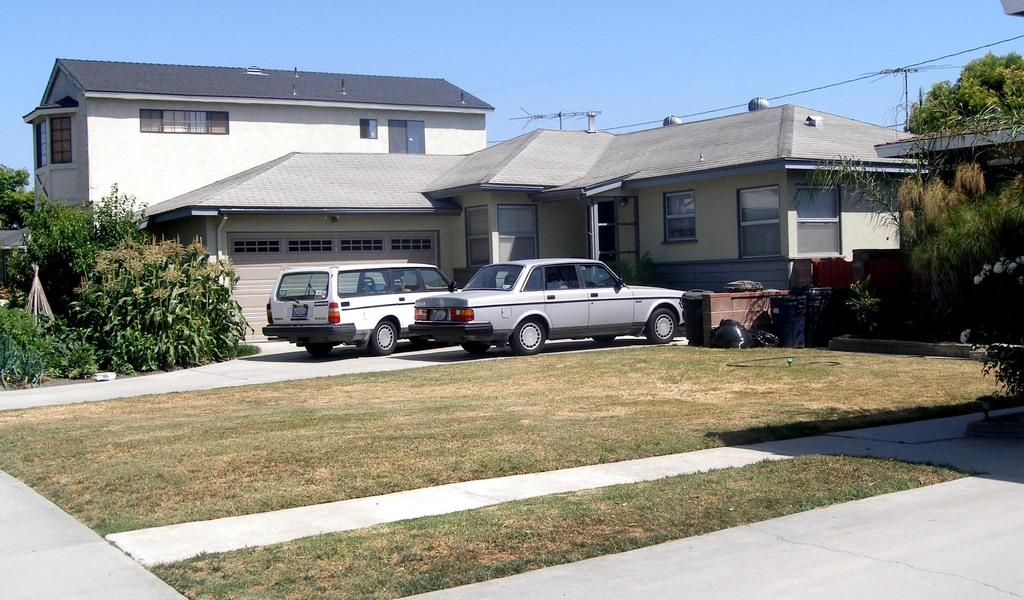What types of man-made structures can be seen in the image? There are buildings in the image. What else can be seen in the image besides buildings? There are vehicles and trees on either side of the image. What is visible at the top of the image? The sky is visible at the top of the image. What type of pest can be seen crawling on the tongue in the image? There is no tongue or pest present in the image. What historical event is depicted in the image? There is no historical event depicted in the image; it features vehicles, buildings, trees, and the sky. 